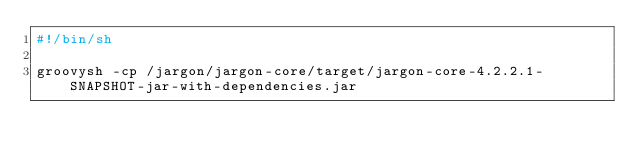<code> <loc_0><loc_0><loc_500><loc_500><_Bash_>#!/bin/sh

groovysh -cp /jargon/jargon-core/target/jargon-core-4.2.2.1-SNAPSHOT-jar-with-dependencies.jar
</code> 